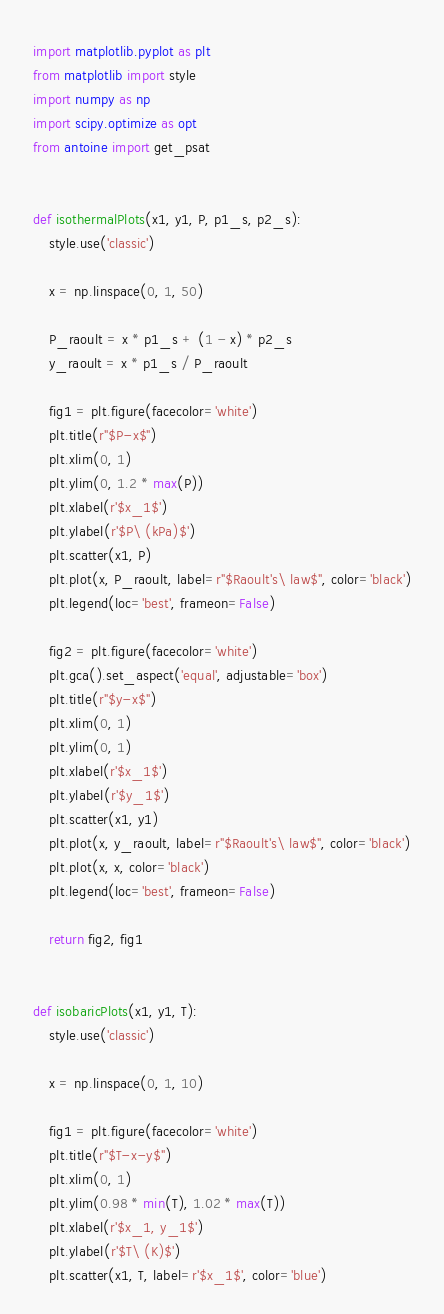<code> <loc_0><loc_0><loc_500><loc_500><_Python_>import matplotlib.pyplot as plt
from matplotlib import style
import numpy as np
import scipy.optimize as opt
from antoine import get_psat


def isothermalPlots(x1, y1, P, p1_s, p2_s):
    style.use('classic')

    x = np.linspace(0, 1, 50)

    P_raoult = x * p1_s + (1 - x) * p2_s
    y_raoult = x * p1_s / P_raoult

    fig1 = plt.figure(facecolor='white')
    plt.title(r"$P-x$")
    plt.xlim(0, 1)
    plt.ylim(0, 1.2 * max(P))
    plt.xlabel(r'$x_1$')
    plt.ylabel(r'$P\ (kPa)$')
    plt.scatter(x1, P)
    plt.plot(x, P_raoult, label=r"$Raoult's\ law$", color='black')
    plt.legend(loc='best', frameon=False)

    fig2 = plt.figure(facecolor='white')
    plt.gca().set_aspect('equal', adjustable='box')
    plt.title(r"$y-x$")
    plt.xlim(0, 1)
    plt.ylim(0, 1)
    plt.xlabel(r'$x_1$')
    plt.ylabel(r'$y_1$')
    plt.scatter(x1, y1)
    plt.plot(x, y_raoult, label=r"$Raoult's\ law$", color='black')
    plt.plot(x, x, color='black')
    plt.legend(loc='best', frameon=False)

    return fig2, fig1


def isobaricPlots(x1, y1, T):
    style.use('classic')

    x = np.linspace(0, 1, 10)

    fig1 = plt.figure(facecolor='white')
    plt.title(r"$T-x-y$")
    plt.xlim(0, 1)
    plt.ylim(0.98 * min(T), 1.02 * max(T))
    plt.xlabel(r'$x_1, y_1$')
    plt.ylabel(r'$T\ (K)$')
    plt.scatter(x1, T, label=r'$x_1$', color='blue')</code> 